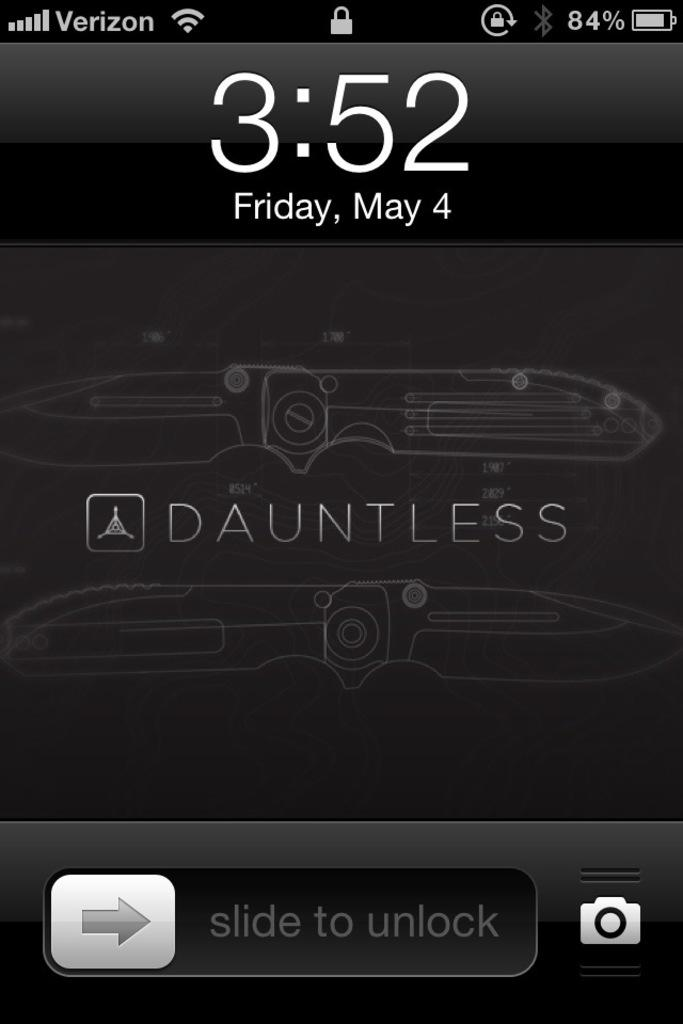<image>
Summarize the visual content of the image. A screen shot of the lock screen of a verison phone at 3:52. 